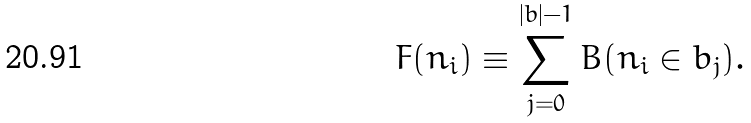Convert formula to latex. <formula><loc_0><loc_0><loc_500><loc_500>F ( n _ { i } ) \equiv \sum _ { j = 0 } ^ { | b | - 1 } B ( n _ { i } \in b _ { j } ) .</formula> 